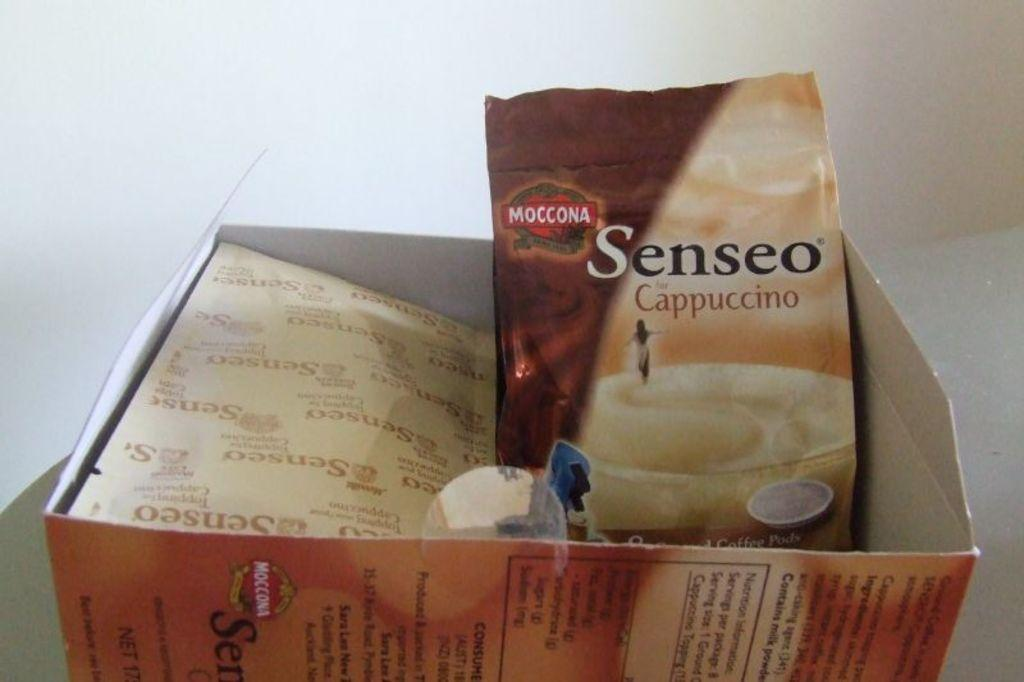<image>
Share a concise interpretation of the image provided. A package of Sensco Cappuccino mix is in a box. 